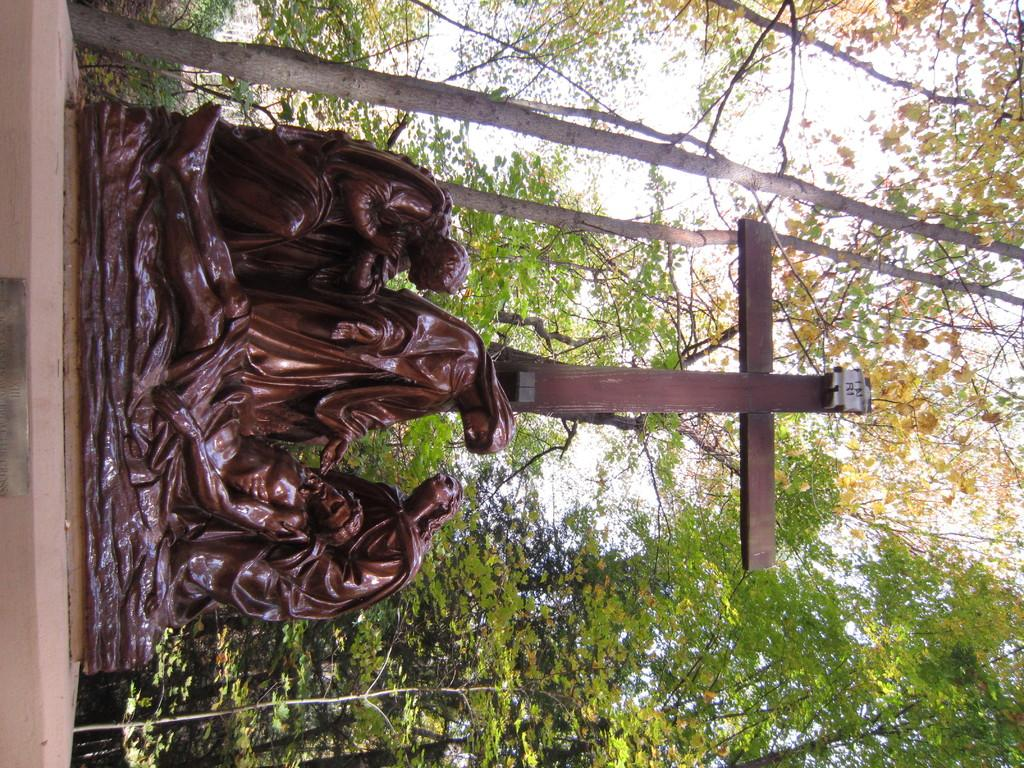What is the main subject of the image? There is a sculpture in the image. What is the sculpture positioned in front of? The sculpture is in front of a cross. What can be seen in the background of the image? There are trees in the background of the image. How many goats are present in the image? There are no goats present in the image. What type of transport is used by the team in the image? There is no team or transport present in the image. 